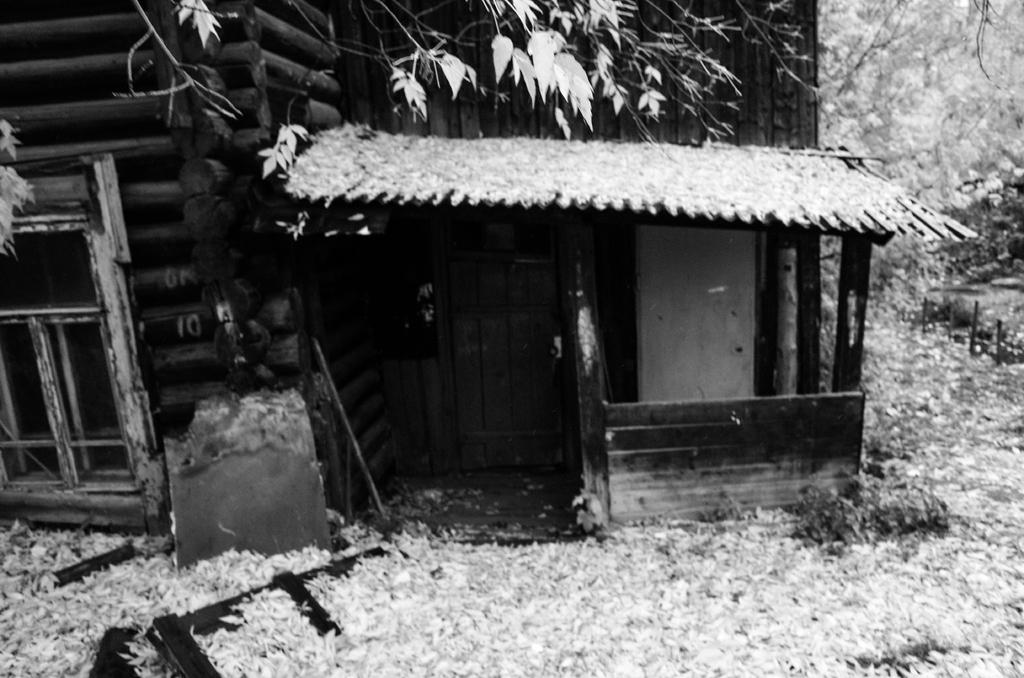What architectural feature can be seen in the image? There is a window in the image. What is another feature that allows access or passage? There is a door in the image. What surrounds the window and door? There are walls in the image. What can be found within the space enclosed by the walls? There are objects in the image. What can be seen in the distance beyond the walls? There are trees visible in the background of the image. What type of vegetable is being grown in the image? There is no vegetable visible in the image; it primarily features architectural elements and trees in the background. Can you see a monkey climbing on the walls in the image? No, there is no monkey present in the image. 